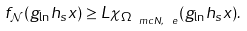Convert formula to latex. <formula><loc_0><loc_0><loc_500><loc_500>f _ { \mathcal { N } } ( g _ { \ln } h _ { s } x ) \geq L \chi _ { \Omega _ { \ m c { N } , \ e } } ( g _ { \ln } h _ { s } x ) .</formula> 